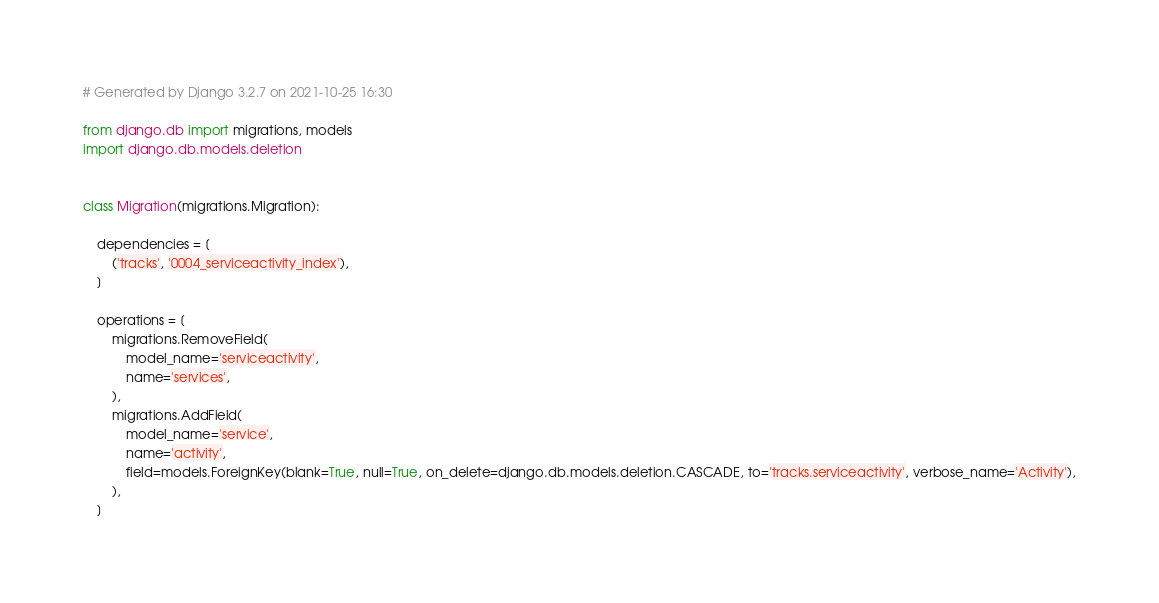Convert code to text. <code><loc_0><loc_0><loc_500><loc_500><_Python_># Generated by Django 3.2.7 on 2021-10-25 16:30

from django.db import migrations, models
import django.db.models.deletion


class Migration(migrations.Migration):

    dependencies = [
        ('tracks', '0004_serviceactivity_index'),
    ]

    operations = [
        migrations.RemoveField(
            model_name='serviceactivity',
            name='services',
        ),
        migrations.AddField(
            model_name='service',
            name='activity',
            field=models.ForeignKey(blank=True, null=True, on_delete=django.db.models.deletion.CASCADE, to='tracks.serviceactivity', verbose_name='Activity'),
        ),
    ]
</code> 